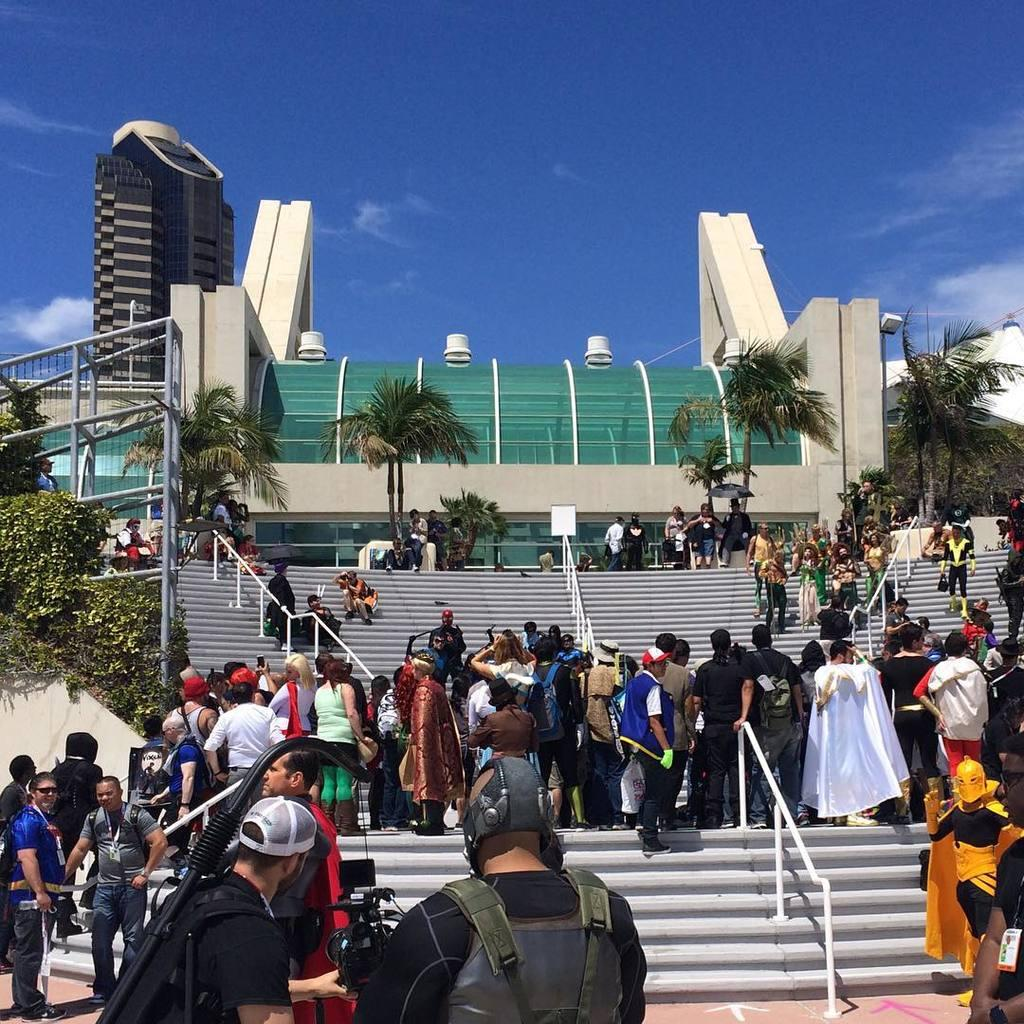What type of structure is visible in the image? There is a building in the image. What other natural elements can be seen in the image? There are trees in the image. Can you describe the people in the image? There are persons sitting on benches, standing on the floor, and standing on the stairs in the image. What architectural features are present in the image? There are railings in the image. What is visible in the sky in the image? The sky is visible in the image, and clouds are present. What type of orange tree can be seen growing on the mountain in the image? There is no orange tree or mountain present in the image. How many pins are being used to hold the persons standing on the stairs in the image? There are no pins present in the image; the persons standing on the stairs are not being held in place by any pins. 